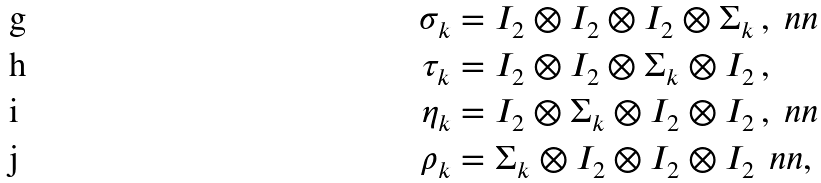<formula> <loc_0><loc_0><loc_500><loc_500>\sigma _ { k } & = I _ { 2 } \otimes I _ { 2 } \otimes I _ { 2 } \otimes \Sigma _ { k } \, , \ n n \\ \tau _ { k } & = I _ { 2 } \otimes I _ { 2 } \otimes \Sigma _ { k } \otimes I _ { 2 } \, , \\ \eta _ { k } & = I _ { 2 } \otimes \Sigma _ { k } \otimes I _ { 2 } \otimes I _ { 2 } \, , \ n n \\ \rho _ { k } & = \Sigma _ { k } \otimes I _ { 2 } \otimes I _ { 2 } \otimes I _ { 2 } \, \ n n ,</formula> 